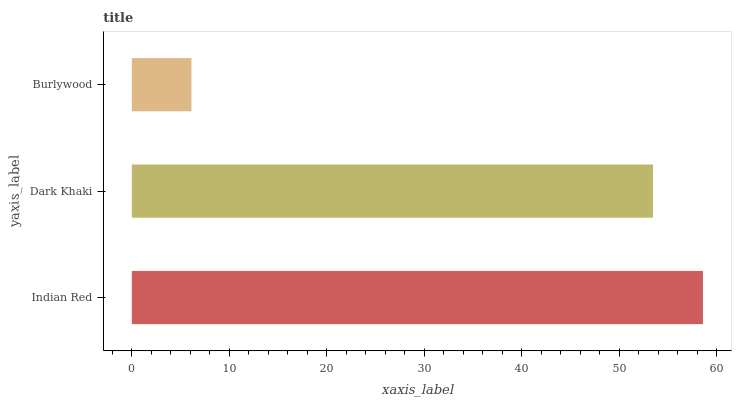Is Burlywood the minimum?
Answer yes or no. Yes. Is Indian Red the maximum?
Answer yes or no. Yes. Is Dark Khaki the minimum?
Answer yes or no. No. Is Dark Khaki the maximum?
Answer yes or no. No. Is Indian Red greater than Dark Khaki?
Answer yes or no. Yes. Is Dark Khaki less than Indian Red?
Answer yes or no. Yes. Is Dark Khaki greater than Indian Red?
Answer yes or no. No. Is Indian Red less than Dark Khaki?
Answer yes or no. No. Is Dark Khaki the high median?
Answer yes or no. Yes. Is Dark Khaki the low median?
Answer yes or no. Yes. Is Indian Red the high median?
Answer yes or no. No. Is Burlywood the low median?
Answer yes or no. No. 